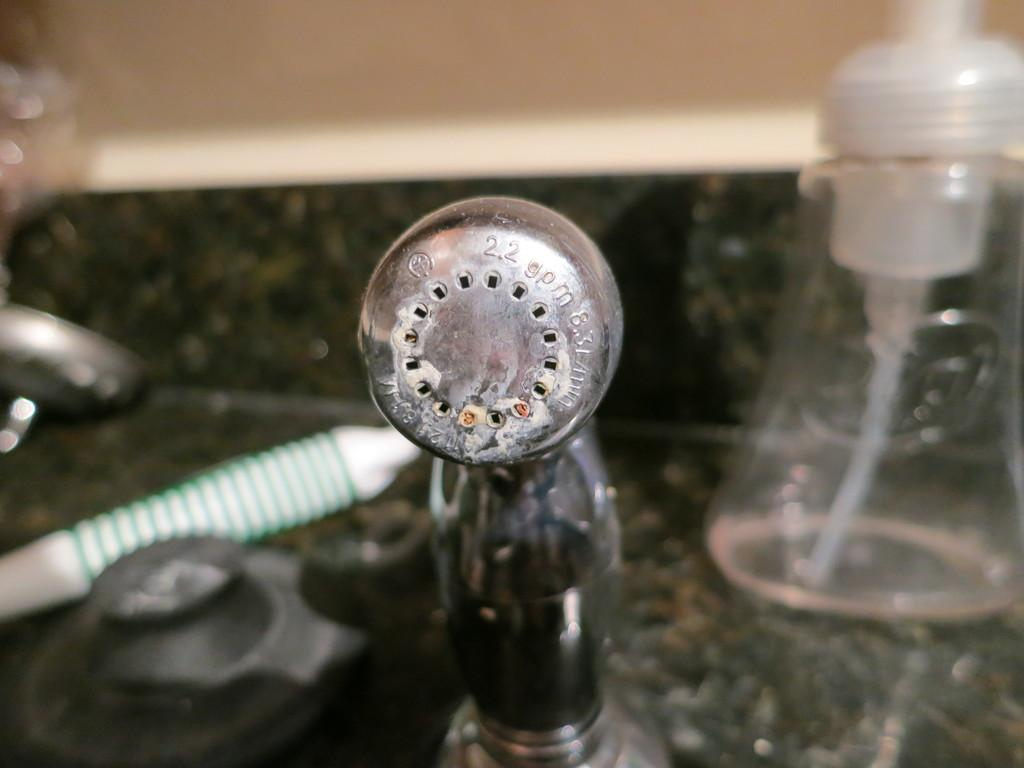What object can be seen in the image that is typically used for holding liquids? There is a bottle in the image that is typically used for holding liquids. What device is present in the image that is used for pumping water? There is a water pumper in the image that is used for pumping water. What type of nail is being used to rub the shade in the image? There is no nail or rubbing of a shade present in the image; it only features a bottle and a water pumper. 